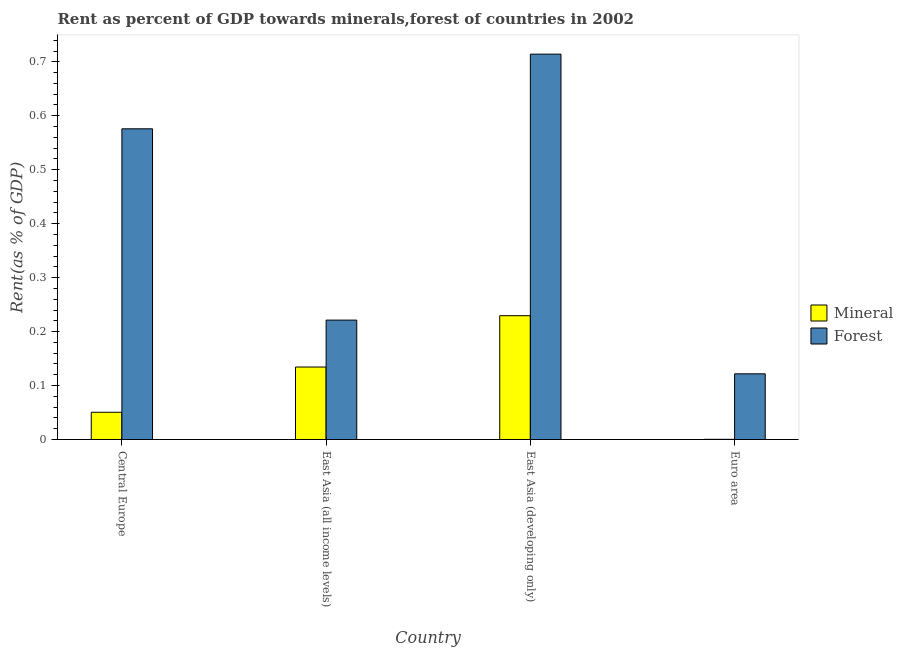How many different coloured bars are there?
Offer a very short reply. 2. How many groups of bars are there?
Provide a succinct answer. 4. Are the number of bars per tick equal to the number of legend labels?
Make the answer very short. Yes. What is the label of the 2nd group of bars from the left?
Provide a short and direct response. East Asia (all income levels). What is the forest rent in Euro area?
Keep it short and to the point. 0.12. Across all countries, what is the maximum mineral rent?
Make the answer very short. 0.23. Across all countries, what is the minimum mineral rent?
Provide a short and direct response. 0. In which country was the forest rent maximum?
Make the answer very short. East Asia (developing only). What is the total mineral rent in the graph?
Provide a short and direct response. 0.41. What is the difference between the mineral rent in East Asia (developing only) and that in Euro area?
Offer a terse response. 0.23. What is the difference between the mineral rent in Euro area and the forest rent in East Asia (all income levels)?
Your response must be concise. -0.22. What is the average forest rent per country?
Offer a very short reply. 0.41. What is the difference between the forest rent and mineral rent in Euro area?
Your response must be concise. 0.12. In how many countries, is the forest rent greater than 0.24000000000000002 %?
Offer a very short reply. 2. What is the ratio of the mineral rent in Central Europe to that in Euro area?
Provide a short and direct response. 131.88. Is the mineral rent in Central Europe less than that in East Asia (all income levels)?
Keep it short and to the point. Yes. What is the difference between the highest and the second highest mineral rent?
Provide a short and direct response. 0.1. What is the difference between the highest and the lowest forest rent?
Your response must be concise. 0.59. In how many countries, is the forest rent greater than the average forest rent taken over all countries?
Provide a succinct answer. 2. What does the 2nd bar from the left in Euro area represents?
Provide a succinct answer. Forest. What does the 2nd bar from the right in Euro area represents?
Provide a succinct answer. Mineral. How many bars are there?
Provide a short and direct response. 8. How many countries are there in the graph?
Offer a very short reply. 4. Are the values on the major ticks of Y-axis written in scientific E-notation?
Your answer should be compact. No. Does the graph contain any zero values?
Give a very brief answer. No. Does the graph contain grids?
Provide a succinct answer. No. Where does the legend appear in the graph?
Offer a terse response. Center right. How many legend labels are there?
Your response must be concise. 2. How are the legend labels stacked?
Your answer should be very brief. Vertical. What is the title of the graph?
Your answer should be very brief. Rent as percent of GDP towards minerals,forest of countries in 2002. Does "Ages 15-24" appear as one of the legend labels in the graph?
Give a very brief answer. No. What is the label or title of the X-axis?
Ensure brevity in your answer.  Country. What is the label or title of the Y-axis?
Ensure brevity in your answer.  Rent(as % of GDP). What is the Rent(as % of GDP) in Mineral in Central Europe?
Make the answer very short. 0.05. What is the Rent(as % of GDP) in Forest in Central Europe?
Make the answer very short. 0.58. What is the Rent(as % of GDP) in Mineral in East Asia (all income levels)?
Keep it short and to the point. 0.13. What is the Rent(as % of GDP) of Forest in East Asia (all income levels)?
Provide a short and direct response. 0.22. What is the Rent(as % of GDP) of Mineral in East Asia (developing only)?
Offer a terse response. 0.23. What is the Rent(as % of GDP) in Forest in East Asia (developing only)?
Provide a short and direct response. 0.71. What is the Rent(as % of GDP) in Mineral in Euro area?
Your response must be concise. 0. What is the Rent(as % of GDP) in Forest in Euro area?
Give a very brief answer. 0.12. Across all countries, what is the maximum Rent(as % of GDP) of Mineral?
Make the answer very short. 0.23. Across all countries, what is the maximum Rent(as % of GDP) in Forest?
Keep it short and to the point. 0.71. Across all countries, what is the minimum Rent(as % of GDP) of Mineral?
Provide a short and direct response. 0. Across all countries, what is the minimum Rent(as % of GDP) of Forest?
Keep it short and to the point. 0.12. What is the total Rent(as % of GDP) in Mineral in the graph?
Make the answer very short. 0.41. What is the total Rent(as % of GDP) of Forest in the graph?
Make the answer very short. 1.63. What is the difference between the Rent(as % of GDP) in Mineral in Central Europe and that in East Asia (all income levels)?
Provide a short and direct response. -0.08. What is the difference between the Rent(as % of GDP) of Forest in Central Europe and that in East Asia (all income levels)?
Your answer should be compact. 0.35. What is the difference between the Rent(as % of GDP) of Mineral in Central Europe and that in East Asia (developing only)?
Ensure brevity in your answer.  -0.18. What is the difference between the Rent(as % of GDP) of Forest in Central Europe and that in East Asia (developing only)?
Offer a very short reply. -0.14. What is the difference between the Rent(as % of GDP) in Mineral in Central Europe and that in Euro area?
Your answer should be compact. 0.05. What is the difference between the Rent(as % of GDP) of Forest in Central Europe and that in Euro area?
Give a very brief answer. 0.45. What is the difference between the Rent(as % of GDP) in Mineral in East Asia (all income levels) and that in East Asia (developing only)?
Make the answer very short. -0.1. What is the difference between the Rent(as % of GDP) in Forest in East Asia (all income levels) and that in East Asia (developing only)?
Offer a very short reply. -0.49. What is the difference between the Rent(as % of GDP) of Mineral in East Asia (all income levels) and that in Euro area?
Offer a terse response. 0.13. What is the difference between the Rent(as % of GDP) in Forest in East Asia (all income levels) and that in Euro area?
Offer a terse response. 0.1. What is the difference between the Rent(as % of GDP) of Mineral in East Asia (developing only) and that in Euro area?
Your response must be concise. 0.23. What is the difference between the Rent(as % of GDP) in Forest in East Asia (developing only) and that in Euro area?
Provide a short and direct response. 0.59. What is the difference between the Rent(as % of GDP) in Mineral in Central Europe and the Rent(as % of GDP) in Forest in East Asia (all income levels)?
Your response must be concise. -0.17. What is the difference between the Rent(as % of GDP) of Mineral in Central Europe and the Rent(as % of GDP) of Forest in East Asia (developing only)?
Keep it short and to the point. -0.66. What is the difference between the Rent(as % of GDP) of Mineral in Central Europe and the Rent(as % of GDP) of Forest in Euro area?
Provide a succinct answer. -0.07. What is the difference between the Rent(as % of GDP) in Mineral in East Asia (all income levels) and the Rent(as % of GDP) in Forest in East Asia (developing only)?
Ensure brevity in your answer.  -0.58. What is the difference between the Rent(as % of GDP) in Mineral in East Asia (all income levels) and the Rent(as % of GDP) in Forest in Euro area?
Make the answer very short. 0.01. What is the difference between the Rent(as % of GDP) in Mineral in East Asia (developing only) and the Rent(as % of GDP) in Forest in Euro area?
Keep it short and to the point. 0.11. What is the average Rent(as % of GDP) in Mineral per country?
Provide a succinct answer. 0.1. What is the average Rent(as % of GDP) of Forest per country?
Provide a short and direct response. 0.41. What is the difference between the Rent(as % of GDP) in Mineral and Rent(as % of GDP) in Forest in Central Europe?
Offer a terse response. -0.53. What is the difference between the Rent(as % of GDP) of Mineral and Rent(as % of GDP) of Forest in East Asia (all income levels)?
Provide a succinct answer. -0.09. What is the difference between the Rent(as % of GDP) in Mineral and Rent(as % of GDP) in Forest in East Asia (developing only)?
Your response must be concise. -0.48. What is the difference between the Rent(as % of GDP) of Mineral and Rent(as % of GDP) of Forest in Euro area?
Provide a succinct answer. -0.12. What is the ratio of the Rent(as % of GDP) in Mineral in Central Europe to that in East Asia (all income levels)?
Provide a succinct answer. 0.38. What is the ratio of the Rent(as % of GDP) of Forest in Central Europe to that in East Asia (all income levels)?
Make the answer very short. 2.6. What is the ratio of the Rent(as % of GDP) in Mineral in Central Europe to that in East Asia (developing only)?
Ensure brevity in your answer.  0.22. What is the ratio of the Rent(as % of GDP) of Forest in Central Europe to that in East Asia (developing only)?
Provide a short and direct response. 0.81. What is the ratio of the Rent(as % of GDP) of Mineral in Central Europe to that in Euro area?
Provide a succinct answer. 131.88. What is the ratio of the Rent(as % of GDP) of Forest in Central Europe to that in Euro area?
Ensure brevity in your answer.  4.73. What is the ratio of the Rent(as % of GDP) of Mineral in East Asia (all income levels) to that in East Asia (developing only)?
Your answer should be very brief. 0.59. What is the ratio of the Rent(as % of GDP) in Forest in East Asia (all income levels) to that in East Asia (developing only)?
Offer a very short reply. 0.31. What is the ratio of the Rent(as % of GDP) of Mineral in East Asia (all income levels) to that in Euro area?
Your answer should be very brief. 350.7. What is the ratio of the Rent(as % of GDP) of Forest in East Asia (all income levels) to that in Euro area?
Keep it short and to the point. 1.82. What is the ratio of the Rent(as % of GDP) in Mineral in East Asia (developing only) to that in Euro area?
Provide a short and direct response. 599.06. What is the ratio of the Rent(as % of GDP) in Forest in East Asia (developing only) to that in Euro area?
Offer a terse response. 5.87. What is the difference between the highest and the second highest Rent(as % of GDP) in Mineral?
Your answer should be very brief. 0.1. What is the difference between the highest and the second highest Rent(as % of GDP) in Forest?
Make the answer very short. 0.14. What is the difference between the highest and the lowest Rent(as % of GDP) in Mineral?
Provide a succinct answer. 0.23. What is the difference between the highest and the lowest Rent(as % of GDP) in Forest?
Offer a terse response. 0.59. 